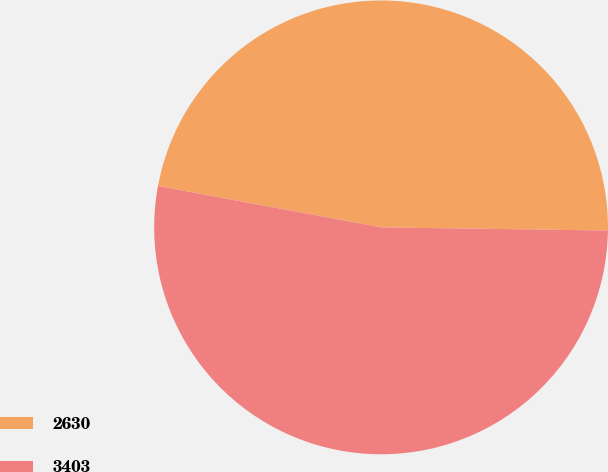<chart> <loc_0><loc_0><loc_500><loc_500><pie_chart><fcel>2630<fcel>3403<nl><fcel>47.3%<fcel>52.7%<nl></chart> 